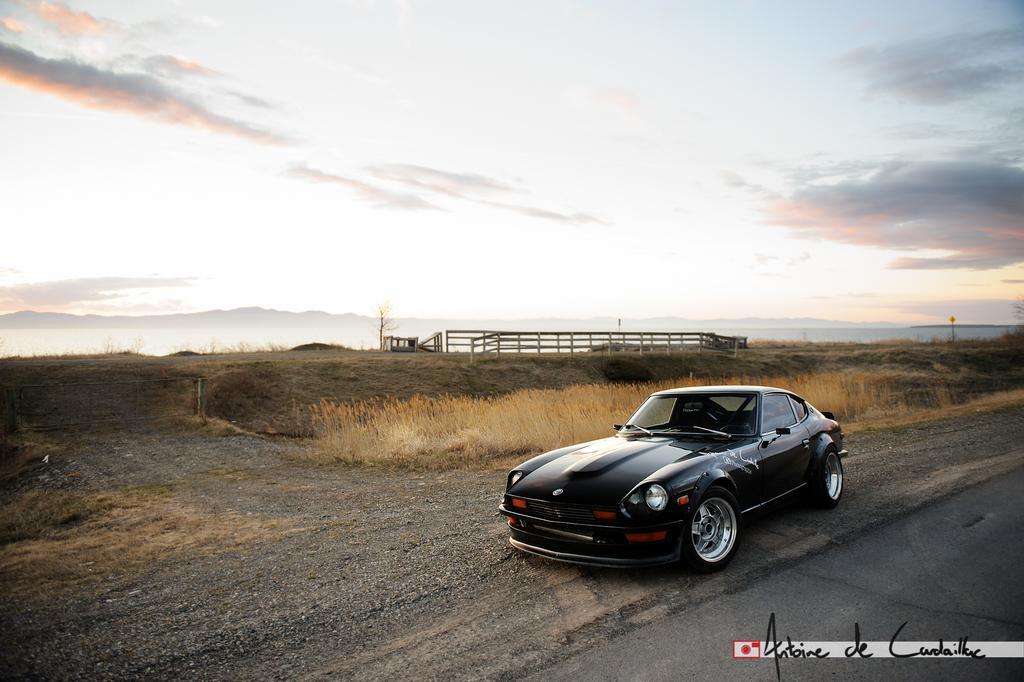Could you give a brief overview of what you see in this image? In this image in the center there is one car and at the bottom there is road and grass, and in the background there are some plants, wooden fence, trees and mountains. And at the top there is sky. 